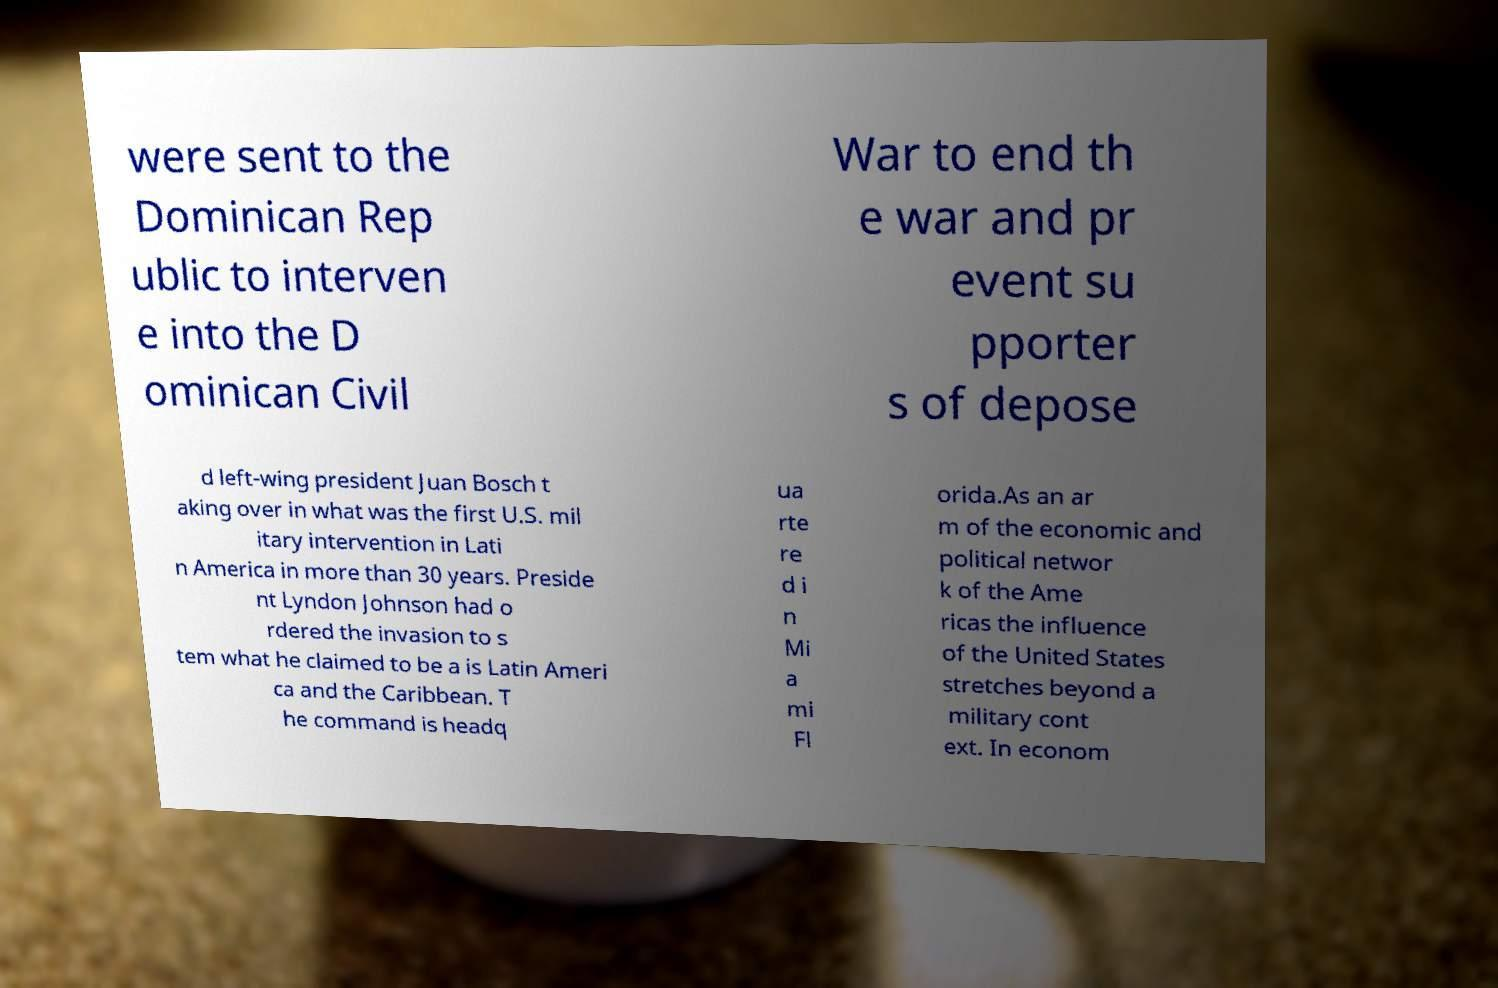There's text embedded in this image that I need extracted. Can you transcribe it verbatim? were sent to the Dominican Rep ublic to interven e into the D ominican Civil War to end th e war and pr event su pporter s of depose d left-wing president Juan Bosch t aking over in what was the first U.S. mil itary intervention in Lati n America in more than 30 years. Preside nt Lyndon Johnson had o rdered the invasion to s tem what he claimed to be a is Latin Ameri ca and the Caribbean. T he command is headq ua rte re d i n Mi a mi Fl orida.As an ar m of the economic and political networ k of the Ame ricas the influence of the United States stretches beyond a military cont ext. In econom 